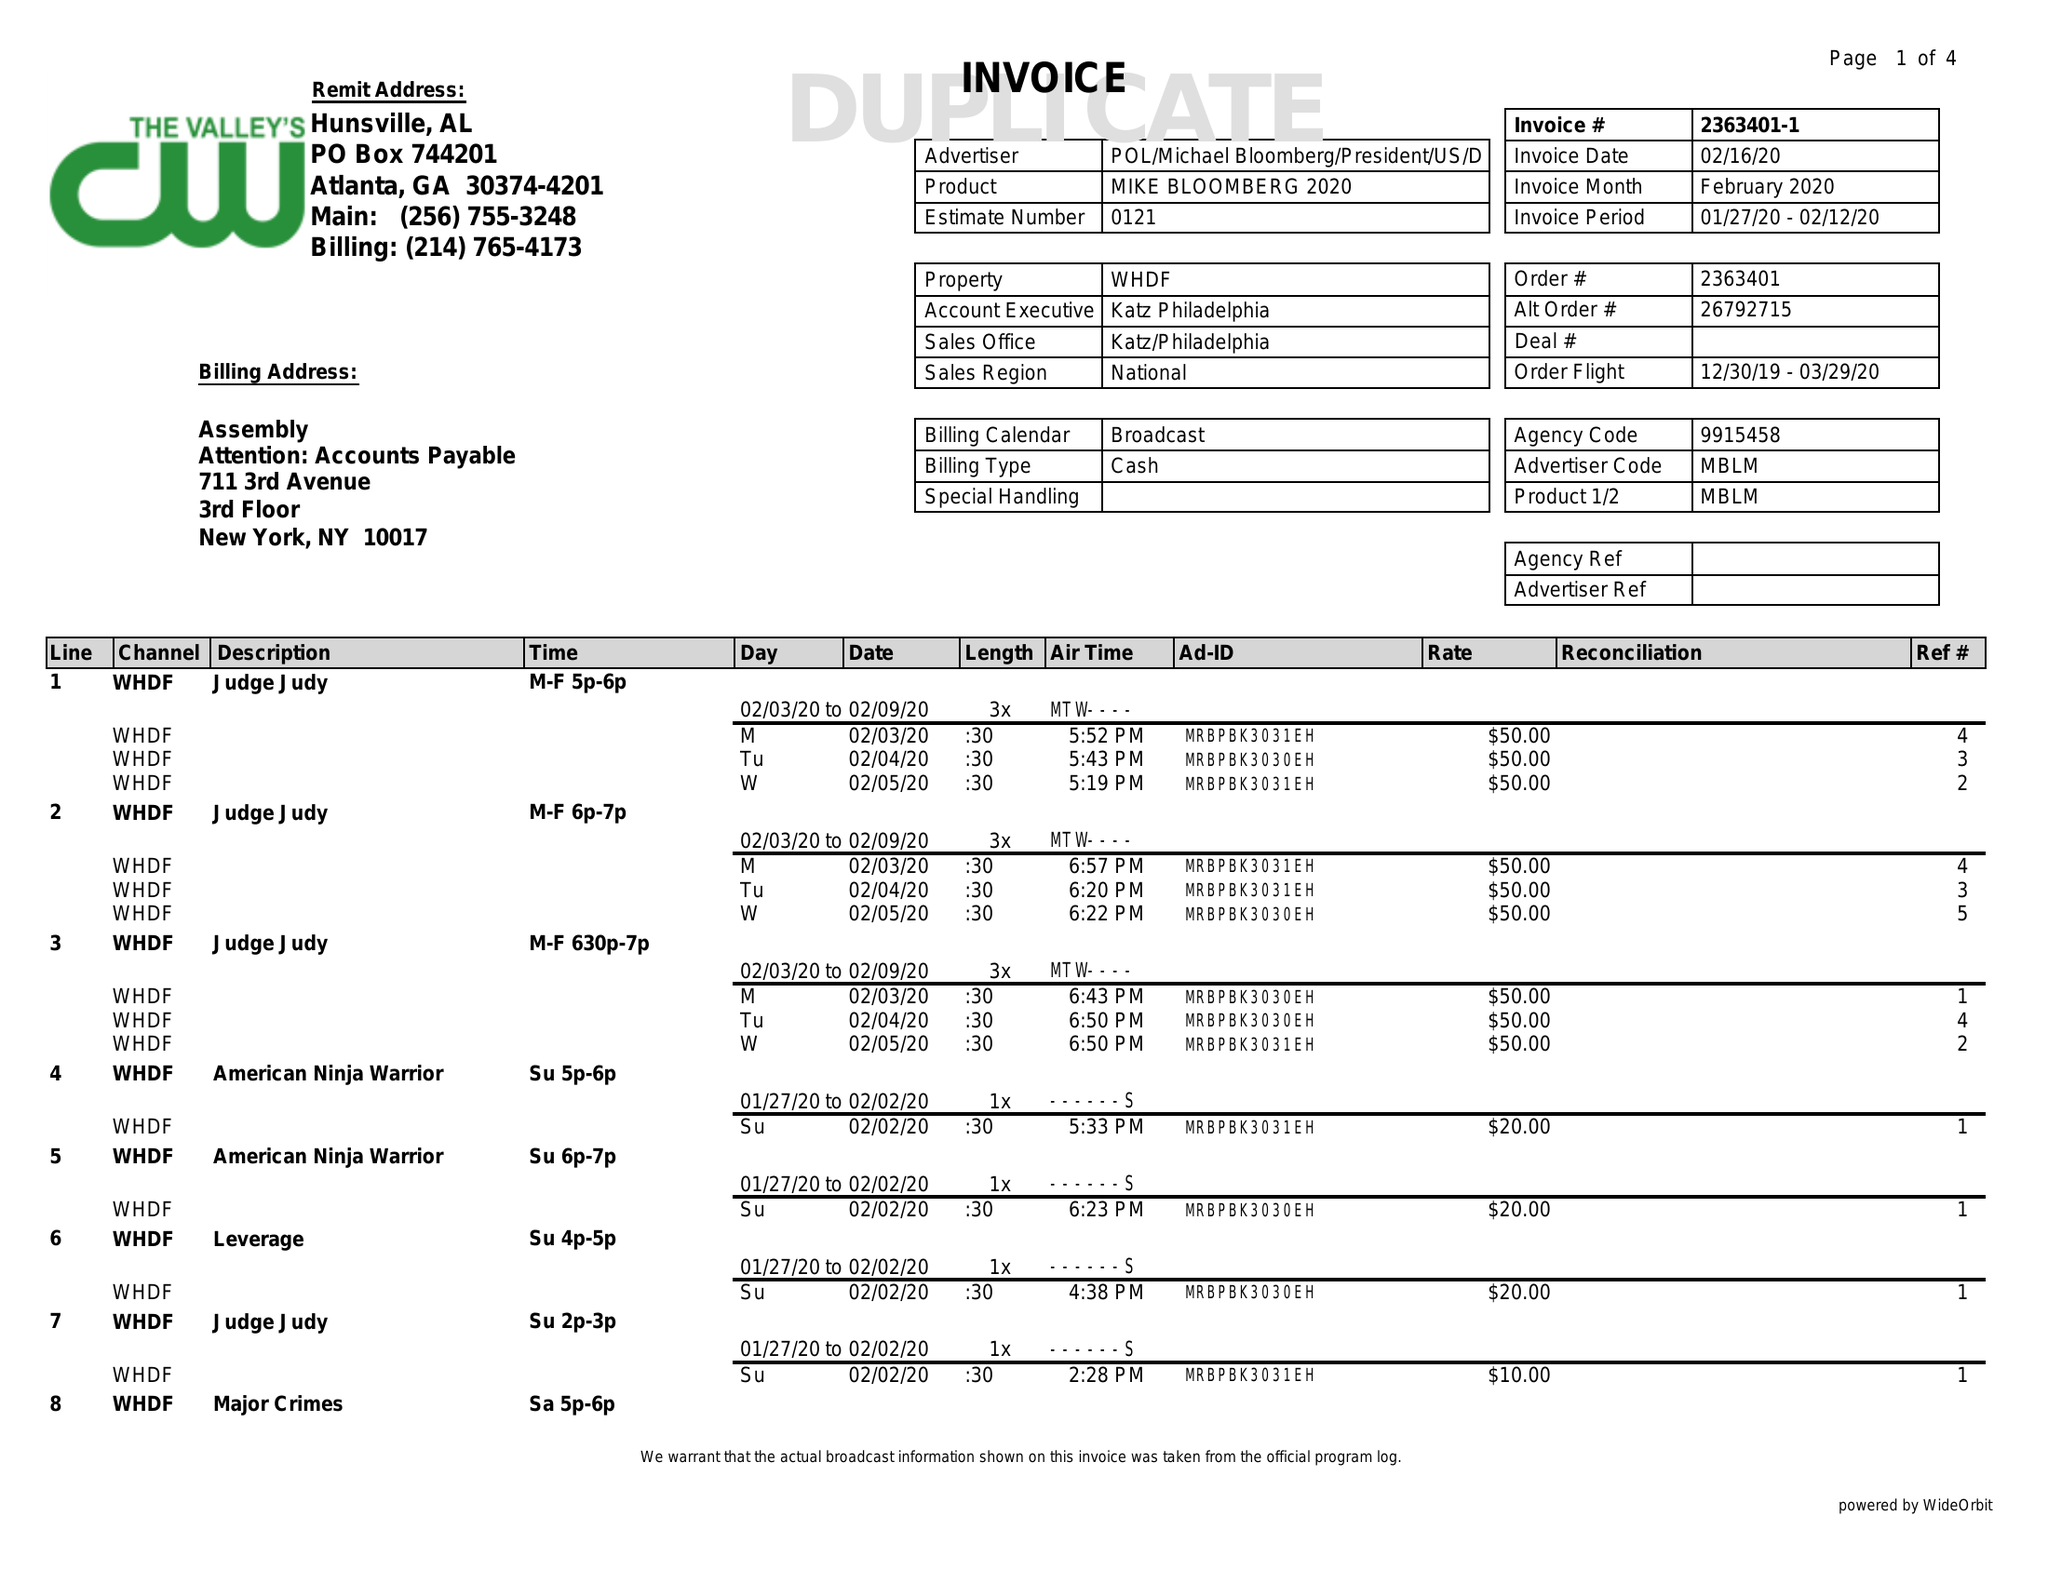What is the value for the flight_from?
Answer the question using a single word or phrase. 12/30/19 